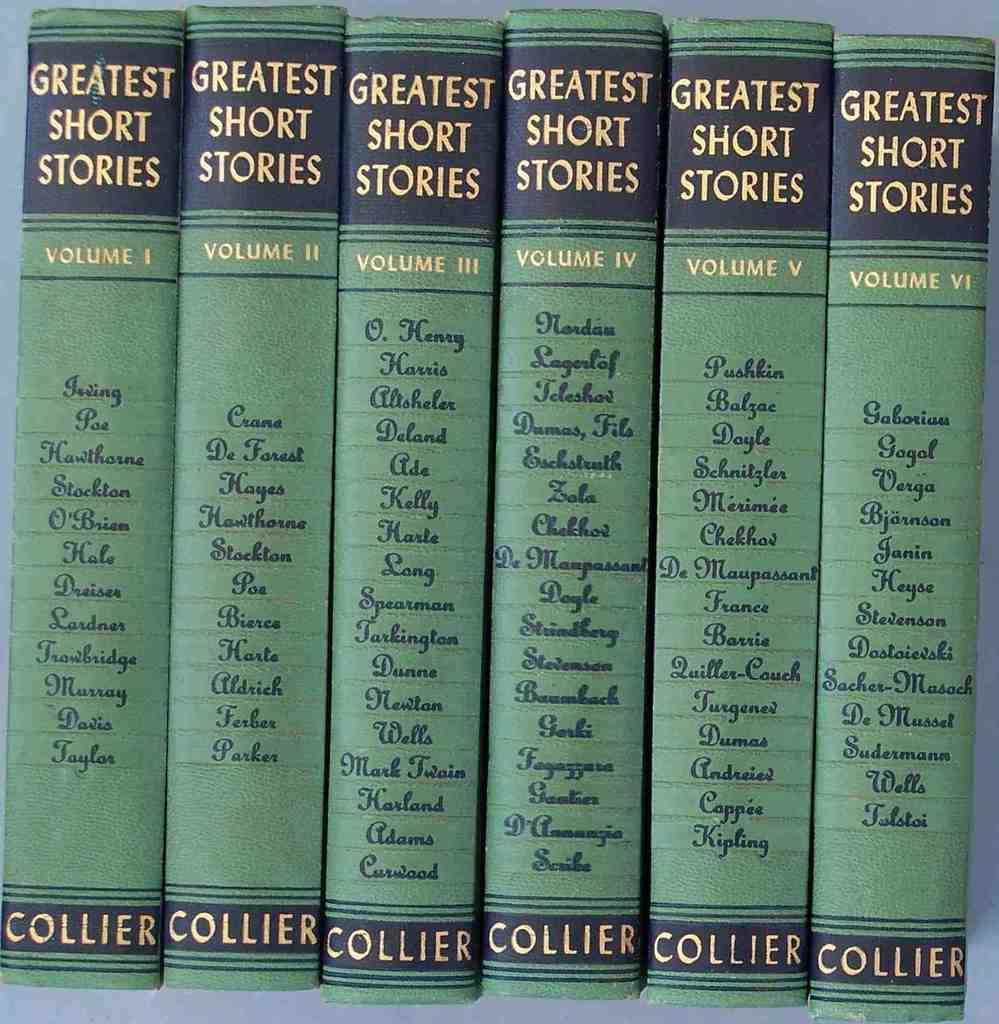Provide a one-sentence caption for the provided image. Six greatest short stories books by Collier are side by side. 